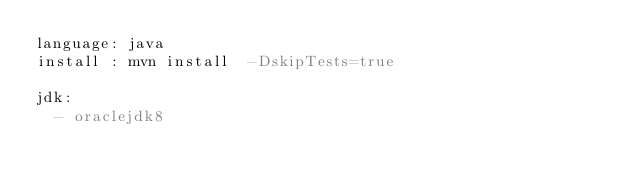Convert code to text. <code><loc_0><loc_0><loc_500><loc_500><_YAML_>language: java
install : mvn install  -DskipTests=true

jdk:
  - oraclejdk8
</code> 